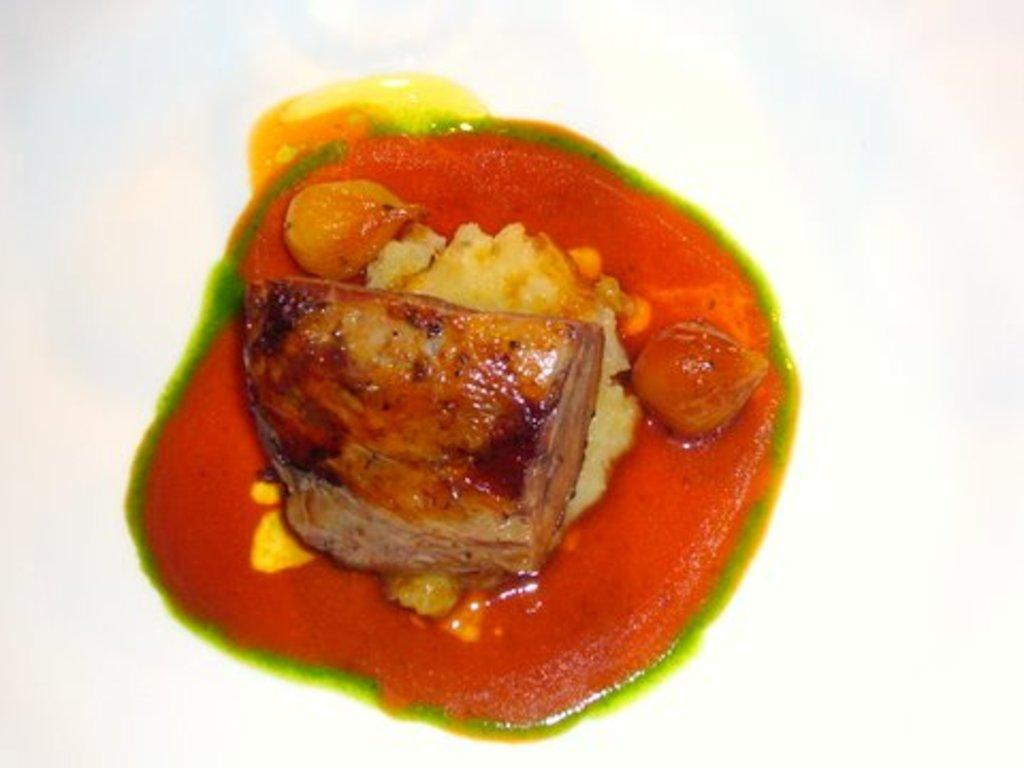What type of food is featured in the center of the image? There are stuffed peppers in the center of the image. Can you describe the arrangement of the stuffed peppers in the image? The stuffed peppers are in the center of the image. What color is the cat sitting next to the stuffed peppers in the image? There is no cat present in the image; it only features stuffed peppers. 